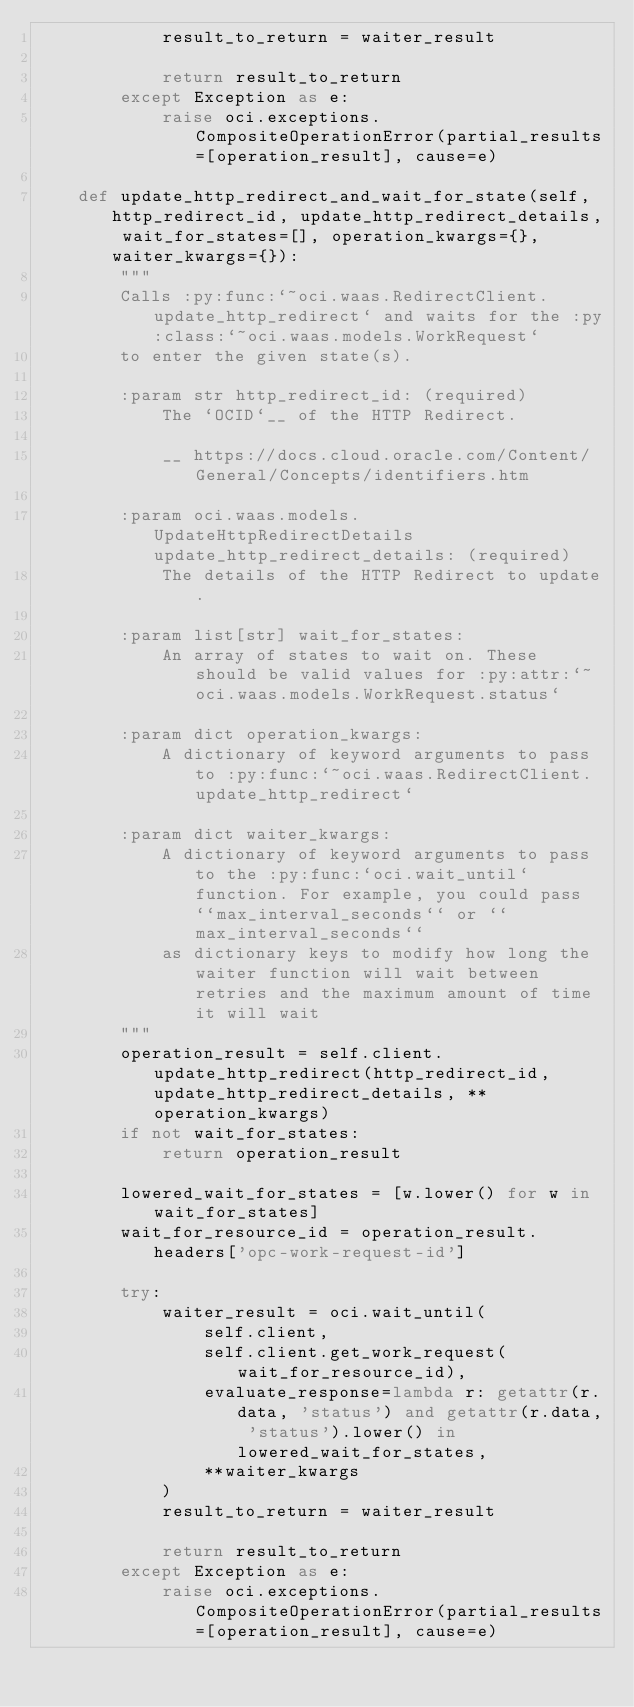<code> <loc_0><loc_0><loc_500><loc_500><_Python_>            result_to_return = waiter_result

            return result_to_return
        except Exception as e:
            raise oci.exceptions.CompositeOperationError(partial_results=[operation_result], cause=e)

    def update_http_redirect_and_wait_for_state(self, http_redirect_id, update_http_redirect_details, wait_for_states=[], operation_kwargs={}, waiter_kwargs={}):
        """
        Calls :py:func:`~oci.waas.RedirectClient.update_http_redirect` and waits for the :py:class:`~oci.waas.models.WorkRequest`
        to enter the given state(s).

        :param str http_redirect_id: (required)
            The `OCID`__ of the HTTP Redirect.

            __ https://docs.cloud.oracle.com/Content/General/Concepts/identifiers.htm

        :param oci.waas.models.UpdateHttpRedirectDetails update_http_redirect_details: (required)
            The details of the HTTP Redirect to update.

        :param list[str] wait_for_states:
            An array of states to wait on. These should be valid values for :py:attr:`~oci.waas.models.WorkRequest.status`

        :param dict operation_kwargs:
            A dictionary of keyword arguments to pass to :py:func:`~oci.waas.RedirectClient.update_http_redirect`

        :param dict waiter_kwargs:
            A dictionary of keyword arguments to pass to the :py:func:`oci.wait_until` function. For example, you could pass ``max_interval_seconds`` or ``max_interval_seconds``
            as dictionary keys to modify how long the waiter function will wait between retries and the maximum amount of time it will wait
        """
        operation_result = self.client.update_http_redirect(http_redirect_id, update_http_redirect_details, **operation_kwargs)
        if not wait_for_states:
            return operation_result

        lowered_wait_for_states = [w.lower() for w in wait_for_states]
        wait_for_resource_id = operation_result.headers['opc-work-request-id']

        try:
            waiter_result = oci.wait_until(
                self.client,
                self.client.get_work_request(wait_for_resource_id),
                evaluate_response=lambda r: getattr(r.data, 'status') and getattr(r.data, 'status').lower() in lowered_wait_for_states,
                **waiter_kwargs
            )
            result_to_return = waiter_result

            return result_to_return
        except Exception as e:
            raise oci.exceptions.CompositeOperationError(partial_results=[operation_result], cause=e)
</code> 